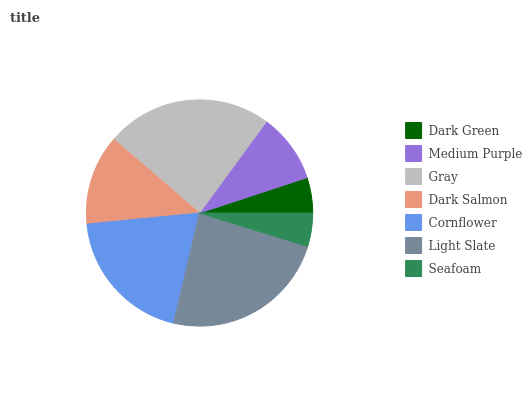Is Seafoam the minimum?
Answer yes or no. Yes. Is Light Slate the maximum?
Answer yes or no. Yes. Is Medium Purple the minimum?
Answer yes or no. No. Is Medium Purple the maximum?
Answer yes or no. No. Is Medium Purple greater than Dark Green?
Answer yes or no. Yes. Is Dark Green less than Medium Purple?
Answer yes or no. Yes. Is Dark Green greater than Medium Purple?
Answer yes or no. No. Is Medium Purple less than Dark Green?
Answer yes or no. No. Is Dark Salmon the high median?
Answer yes or no. Yes. Is Dark Salmon the low median?
Answer yes or no. Yes. Is Seafoam the high median?
Answer yes or no. No. Is Seafoam the low median?
Answer yes or no. No. 